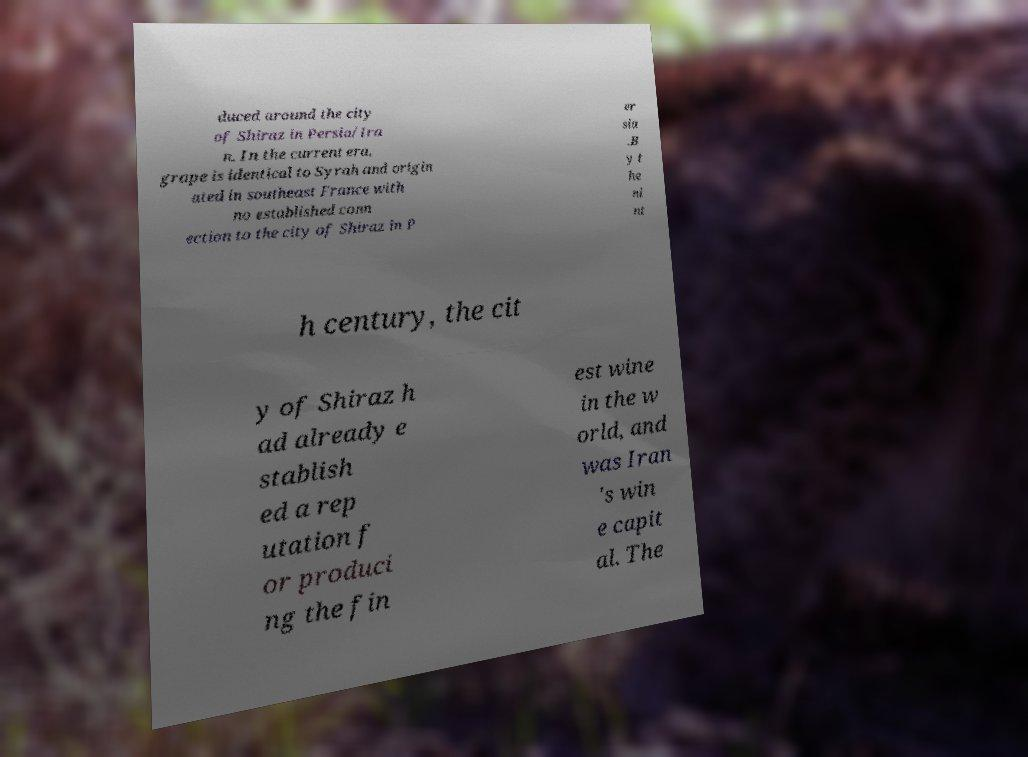Can you accurately transcribe the text from the provided image for me? duced around the city of Shiraz in Persia/Ira n. In the current era, grape is identical to Syrah and origin ated in southeast France with no established conn ection to the city of Shiraz in P er sia .B y t he ni nt h century, the cit y of Shiraz h ad already e stablish ed a rep utation f or produci ng the fin est wine in the w orld, and was Iran 's win e capit al. The 